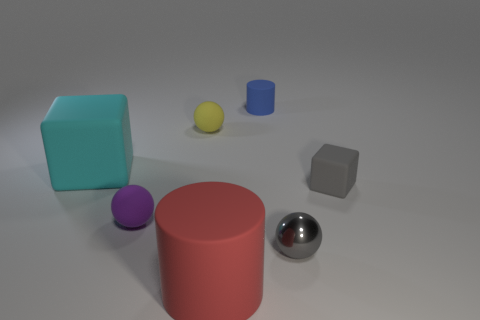How many objects are cylinders behind the tiny metallic thing or rubber blocks that are left of the yellow sphere?
Your response must be concise. 2. What material is the small gray ball?
Keep it short and to the point. Metal. How many other things are there of the same size as the gray matte thing?
Give a very brief answer. 4. There is a matte block to the left of the yellow rubber thing; how big is it?
Offer a terse response. Large. There is a cylinder behind the small sphere behind the rubber cube that is behind the tiny gray rubber cube; what is its material?
Ensure brevity in your answer.  Rubber. Is the shape of the blue thing the same as the large cyan matte thing?
Your response must be concise. No. How many matte objects are red cylinders or tiny blue cylinders?
Make the answer very short. 2. What number of large cubes are there?
Your answer should be very brief. 1. There is another matte sphere that is the same size as the purple matte ball; what color is it?
Offer a very short reply. Yellow. Is the purple matte sphere the same size as the cyan rubber cube?
Offer a very short reply. No. 